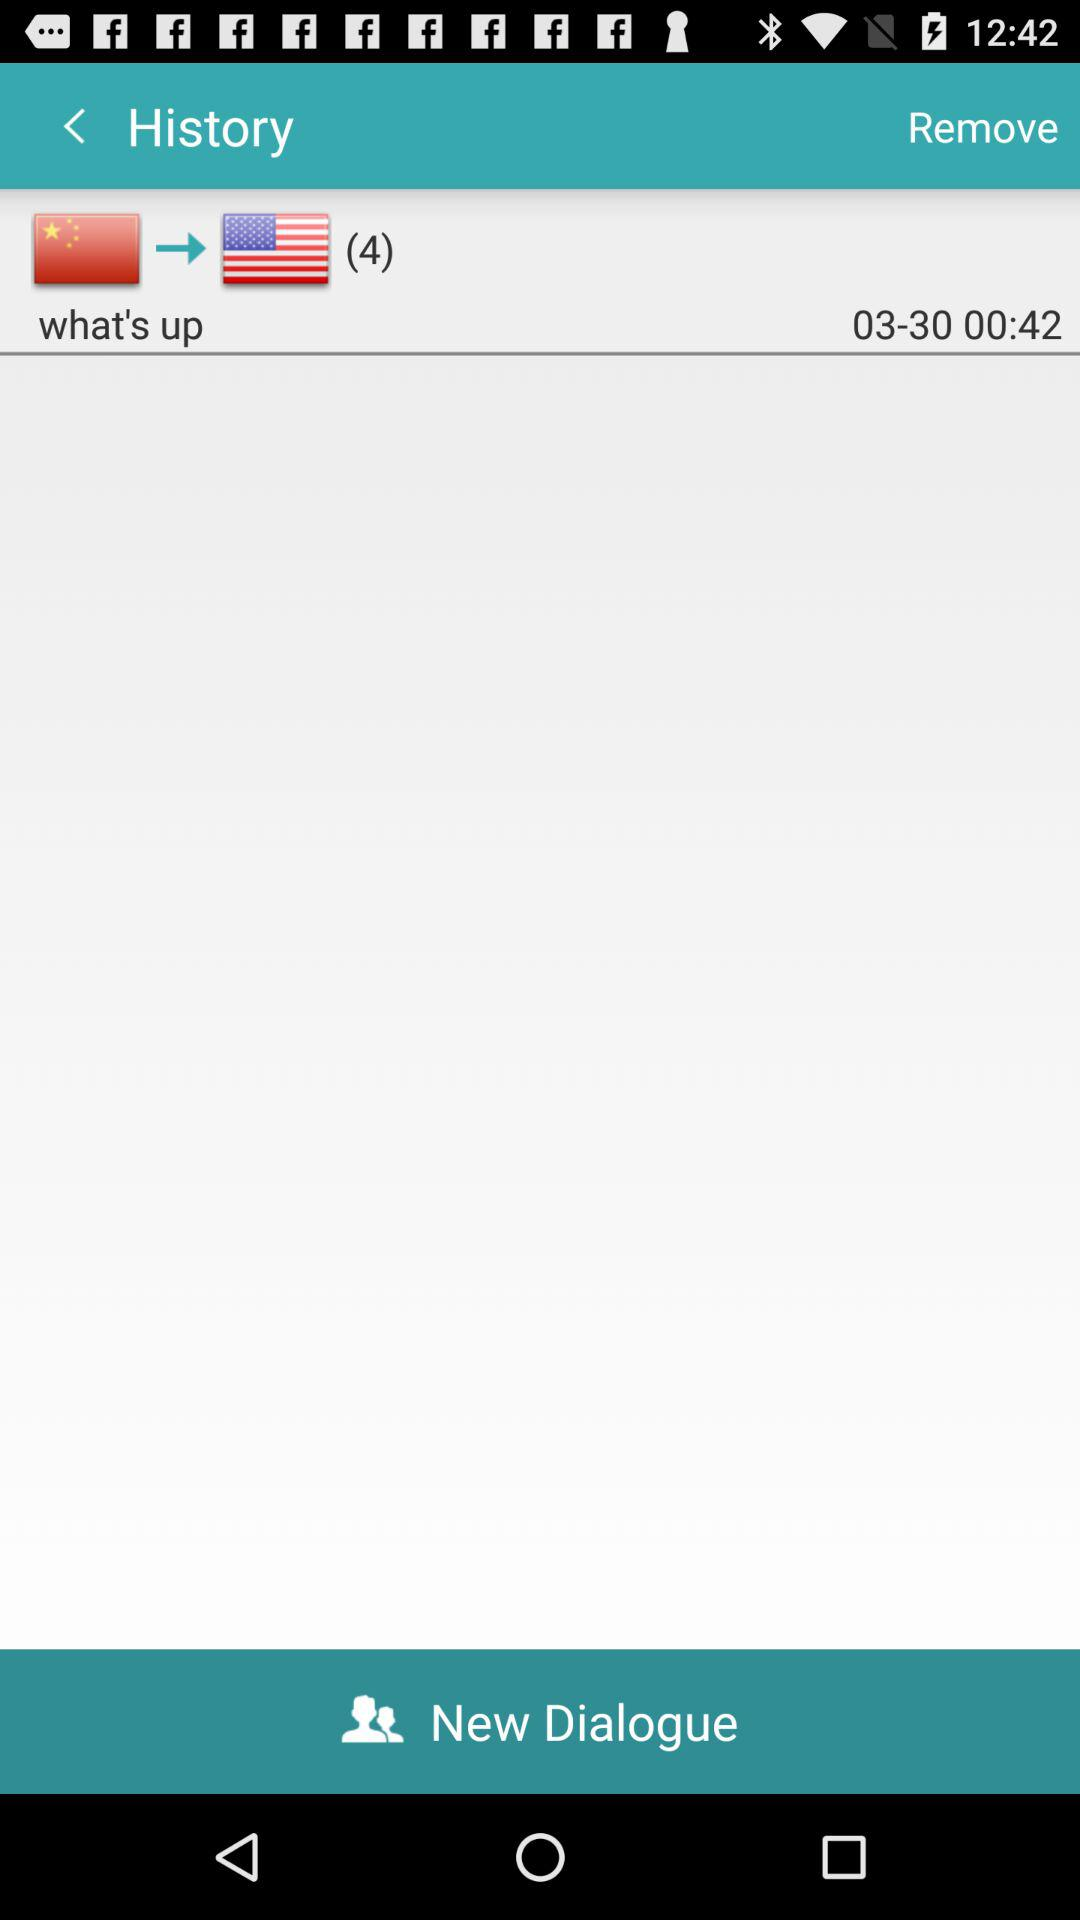How many messages does the user have?
Answer the question using a single word or phrase. 4 